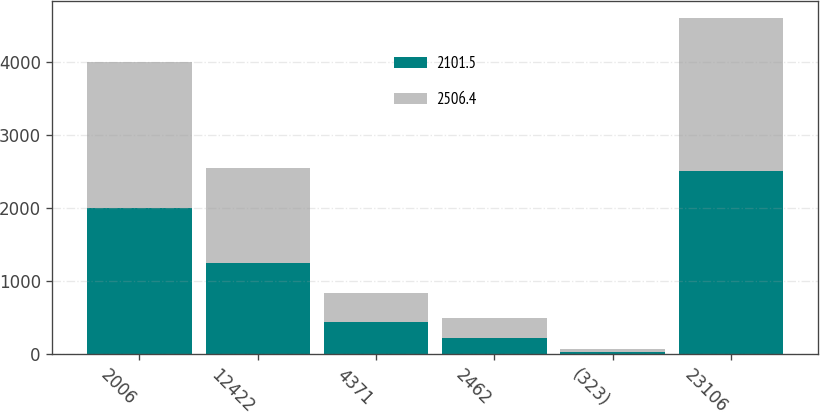<chart> <loc_0><loc_0><loc_500><loc_500><stacked_bar_chart><ecel><fcel>2006<fcel>12422<fcel>4371<fcel>2462<fcel>(323)<fcel>23106<nl><fcel>2101.5<fcel>2005<fcel>1253.2<fcel>446.9<fcel>226.3<fcel>27.2<fcel>2506.4<nl><fcel>2506.4<fcel>2004<fcel>1302.5<fcel>387.1<fcel>269.5<fcel>51.2<fcel>2101.5<nl></chart> 